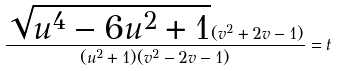<formula> <loc_0><loc_0><loc_500><loc_500>\frac { \sqrt { u ^ { 4 } - 6 u ^ { 2 } + 1 } ( v ^ { 2 } + 2 v - 1 ) } { ( u ^ { 2 } + 1 ) ( v ^ { 2 } - 2 v - 1 ) } = t</formula> 